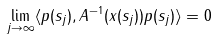<formula> <loc_0><loc_0><loc_500><loc_500>\lim _ { j \to \infty } \langle p ( s _ { j } ) , A ^ { - 1 } ( x ( s _ { j } ) ) p ( s _ { j } ) \rangle = 0</formula> 